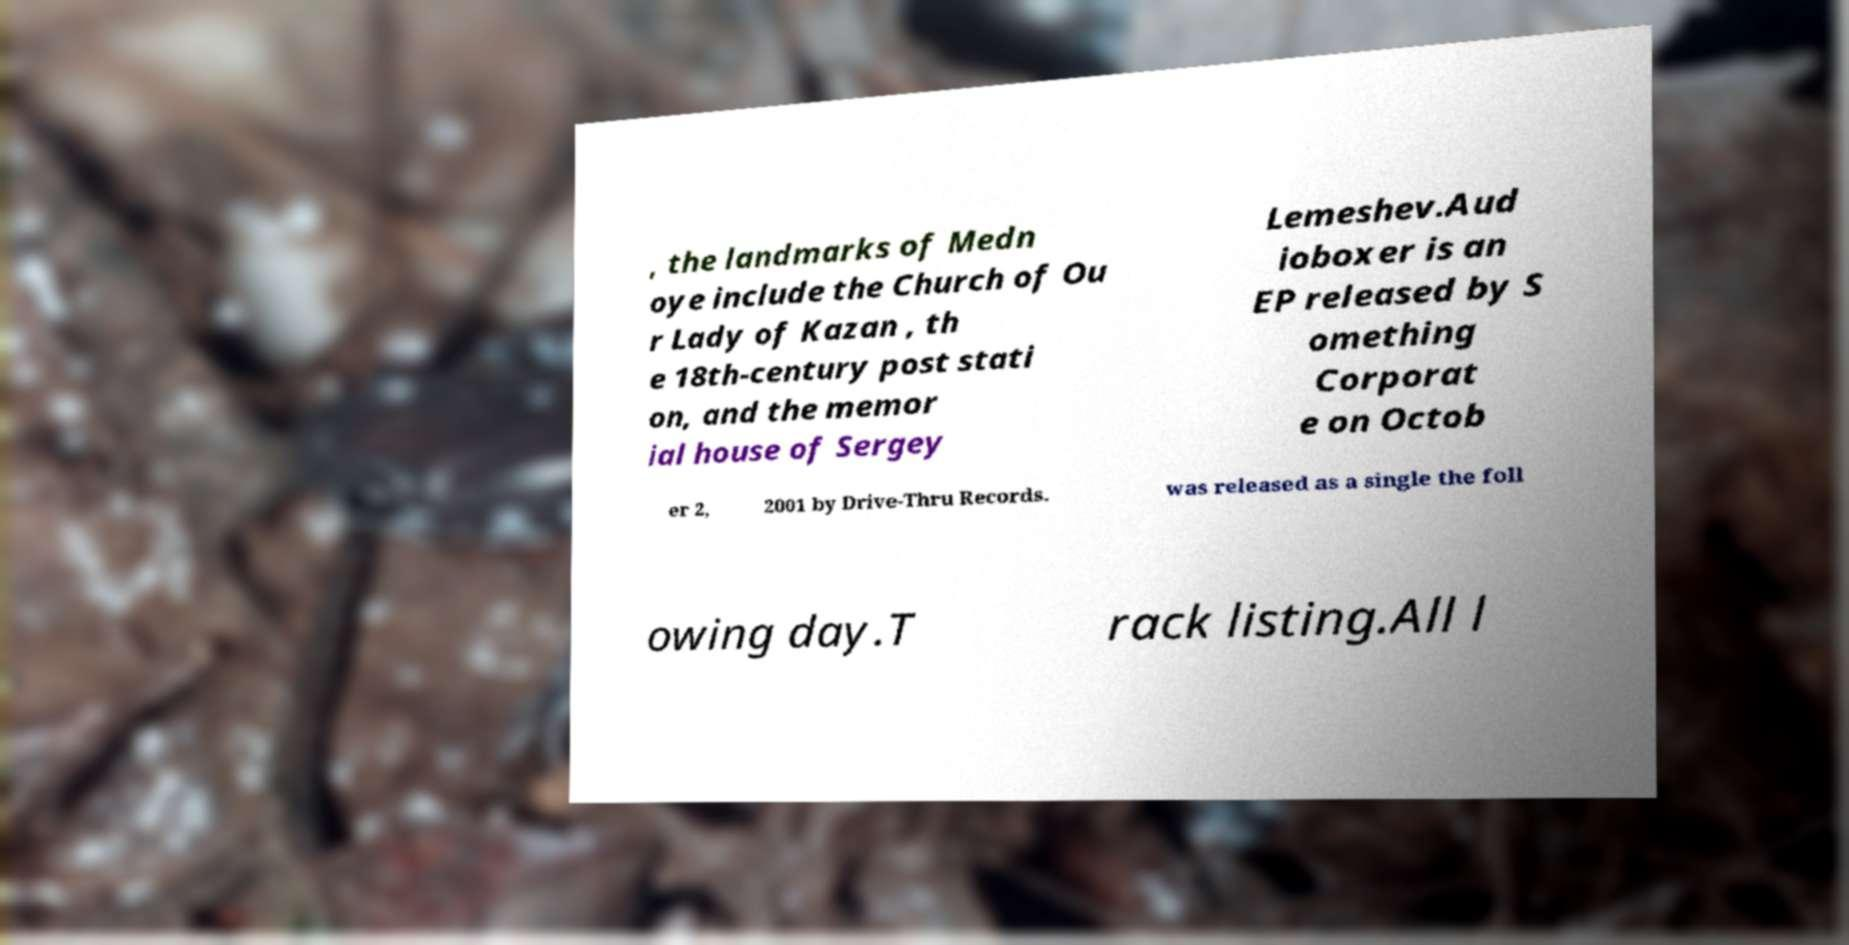For documentation purposes, I need the text within this image transcribed. Could you provide that? , the landmarks of Medn oye include the Church of Ou r Lady of Kazan , th e 18th-century post stati on, and the memor ial house of Sergey Lemeshev.Aud ioboxer is an EP released by S omething Corporat e on Octob er 2, 2001 by Drive-Thru Records. was released as a single the foll owing day.T rack listing.All l 